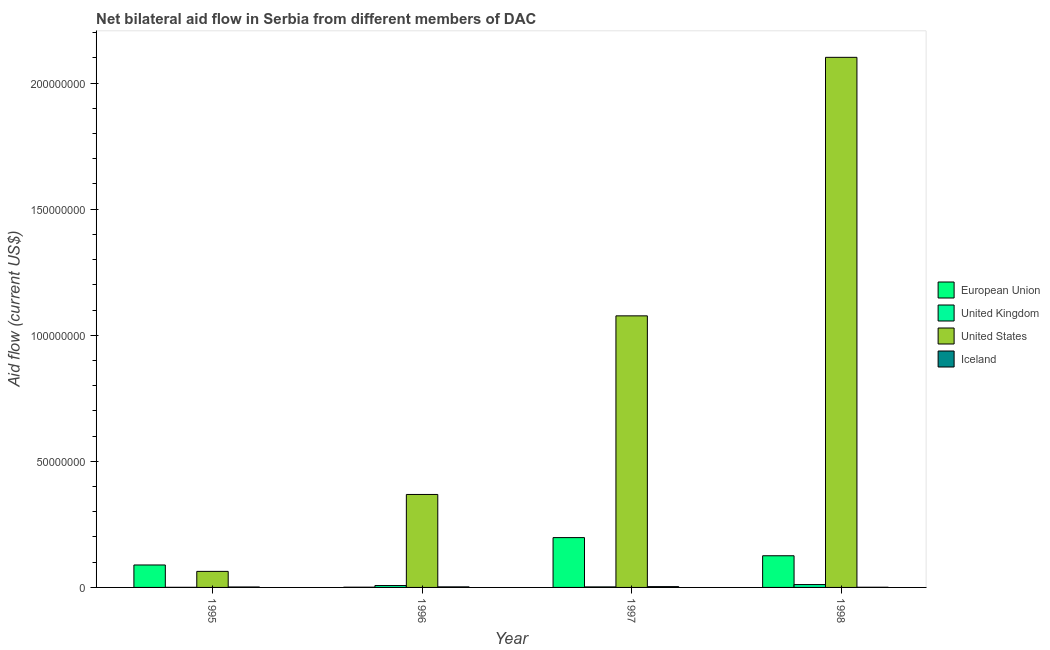How many different coloured bars are there?
Provide a succinct answer. 4. Are the number of bars on each tick of the X-axis equal?
Provide a succinct answer. Yes. How many bars are there on the 4th tick from the left?
Keep it short and to the point. 4. What is the amount of aid given by us in 1998?
Keep it short and to the point. 2.10e+08. Across all years, what is the maximum amount of aid given by uk?
Give a very brief answer. 1.13e+06. Across all years, what is the minimum amount of aid given by uk?
Provide a short and direct response. 4.00e+04. In which year was the amount of aid given by eu maximum?
Offer a very short reply. 1997. In which year was the amount of aid given by us minimum?
Offer a terse response. 1995. What is the total amount of aid given by iceland in the graph?
Offer a terse response. 7.90e+05. What is the difference between the amount of aid given by us in 1996 and that in 1997?
Your answer should be compact. -7.08e+07. What is the difference between the amount of aid given by uk in 1995 and the amount of aid given by eu in 1996?
Your response must be concise. -7.10e+05. What is the average amount of aid given by us per year?
Offer a terse response. 9.03e+07. In how many years, is the amount of aid given by iceland greater than 40000000 US$?
Offer a terse response. 0. What is the ratio of the amount of aid given by us in 1995 to that in 1996?
Offer a very short reply. 0.17. Is the amount of aid given by iceland in 1995 less than that in 1998?
Offer a very short reply. No. Is the difference between the amount of aid given by us in 1995 and 1996 greater than the difference between the amount of aid given by iceland in 1995 and 1996?
Your response must be concise. No. What is the difference between the highest and the second highest amount of aid given by iceland?
Ensure brevity in your answer.  1.00e+05. What is the difference between the highest and the lowest amount of aid given by eu?
Your answer should be very brief. 1.97e+07. Is the sum of the amount of aid given by eu in 1997 and 1998 greater than the maximum amount of aid given by iceland across all years?
Offer a very short reply. Yes. What does the 2nd bar from the left in 1998 represents?
Give a very brief answer. United Kingdom. Is it the case that in every year, the sum of the amount of aid given by eu and amount of aid given by uk is greater than the amount of aid given by us?
Your answer should be very brief. No. Are all the bars in the graph horizontal?
Your answer should be compact. No. What is the difference between two consecutive major ticks on the Y-axis?
Your answer should be compact. 5.00e+07. Are the values on the major ticks of Y-axis written in scientific E-notation?
Give a very brief answer. No. Does the graph contain any zero values?
Give a very brief answer. No. Does the graph contain grids?
Provide a short and direct response. No. Where does the legend appear in the graph?
Ensure brevity in your answer.  Center right. What is the title of the graph?
Your response must be concise. Net bilateral aid flow in Serbia from different members of DAC. Does "United Kingdom" appear as one of the legend labels in the graph?
Your answer should be very brief. Yes. What is the Aid flow (current US$) of European Union in 1995?
Give a very brief answer. 8.90e+06. What is the Aid flow (current US$) in United States in 1995?
Your answer should be compact. 6.36e+06. What is the Aid flow (current US$) in United Kingdom in 1996?
Your response must be concise. 7.50e+05. What is the Aid flow (current US$) in United States in 1996?
Provide a succinct answer. 3.69e+07. What is the Aid flow (current US$) in European Union in 1997?
Your response must be concise. 1.98e+07. What is the Aid flow (current US$) of United States in 1997?
Provide a short and direct response. 1.08e+08. What is the Aid flow (current US$) in European Union in 1998?
Offer a terse response. 1.26e+07. What is the Aid flow (current US$) of United Kingdom in 1998?
Your answer should be very brief. 1.13e+06. What is the Aid flow (current US$) in United States in 1998?
Make the answer very short. 2.10e+08. What is the Aid flow (current US$) in Iceland in 1998?
Ensure brevity in your answer.  7.00e+04. Across all years, what is the maximum Aid flow (current US$) of European Union?
Offer a terse response. 1.98e+07. Across all years, what is the maximum Aid flow (current US$) of United Kingdom?
Keep it short and to the point. 1.13e+06. Across all years, what is the maximum Aid flow (current US$) in United States?
Provide a succinct answer. 2.10e+08. Across all years, what is the maximum Aid flow (current US$) of Iceland?
Your answer should be compact. 3.20e+05. Across all years, what is the minimum Aid flow (current US$) of European Union?
Make the answer very short. 9.00e+04. Across all years, what is the minimum Aid flow (current US$) of United Kingdom?
Your answer should be compact. 4.00e+04. Across all years, what is the minimum Aid flow (current US$) in United States?
Your answer should be compact. 6.36e+06. What is the total Aid flow (current US$) in European Union in the graph?
Provide a short and direct response. 4.13e+07. What is the total Aid flow (current US$) in United Kingdom in the graph?
Provide a short and direct response. 2.13e+06. What is the total Aid flow (current US$) in United States in the graph?
Your response must be concise. 3.61e+08. What is the total Aid flow (current US$) of Iceland in the graph?
Your answer should be very brief. 7.90e+05. What is the difference between the Aid flow (current US$) in European Union in 1995 and that in 1996?
Keep it short and to the point. 8.81e+06. What is the difference between the Aid flow (current US$) in United Kingdom in 1995 and that in 1996?
Give a very brief answer. -7.10e+05. What is the difference between the Aid flow (current US$) in United States in 1995 and that in 1996?
Provide a succinct answer. -3.05e+07. What is the difference between the Aid flow (current US$) of Iceland in 1995 and that in 1996?
Your answer should be compact. -4.00e+04. What is the difference between the Aid flow (current US$) of European Union in 1995 and that in 1997?
Offer a very short reply. -1.09e+07. What is the difference between the Aid flow (current US$) in United Kingdom in 1995 and that in 1997?
Offer a very short reply. -1.70e+05. What is the difference between the Aid flow (current US$) in United States in 1995 and that in 1997?
Make the answer very short. -1.01e+08. What is the difference between the Aid flow (current US$) in Iceland in 1995 and that in 1997?
Ensure brevity in your answer.  -1.40e+05. What is the difference between the Aid flow (current US$) in European Union in 1995 and that in 1998?
Offer a terse response. -3.66e+06. What is the difference between the Aid flow (current US$) of United Kingdom in 1995 and that in 1998?
Offer a terse response. -1.09e+06. What is the difference between the Aid flow (current US$) of United States in 1995 and that in 1998?
Keep it short and to the point. -2.04e+08. What is the difference between the Aid flow (current US$) in Iceland in 1995 and that in 1998?
Offer a very short reply. 1.10e+05. What is the difference between the Aid flow (current US$) of European Union in 1996 and that in 1997?
Offer a very short reply. -1.97e+07. What is the difference between the Aid flow (current US$) of United Kingdom in 1996 and that in 1997?
Keep it short and to the point. 5.40e+05. What is the difference between the Aid flow (current US$) in United States in 1996 and that in 1997?
Ensure brevity in your answer.  -7.08e+07. What is the difference between the Aid flow (current US$) of Iceland in 1996 and that in 1997?
Give a very brief answer. -1.00e+05. What is the difference between the Aid flow (current US$) in European Union in 1996 and that in 1998?
Make the answer very short. -1.25e+07. What is the difference between the Aid flow (current US$) in United Kingdom in 1996 and that in 1998?
Provide a short and direct response. -3.80e+05. What is the difference between the Aid flow (current US$) in United States in 1996 and that in 1998?
Provide a succinct answer. -1.73e+08. What is the difference between the Aid flow (current US$) of European Union in 1997 and that in 1998?
Your answer should be compact. 7.20e+06. What is the difference between the Aid flow (current US$) in United Kingdom in 1997 and that in 1998?
Offer a very short reply. -9.20e+05. What is the difference between the Aid flow (current US$) of United States in 1997 and that in 1998?
Offer a very short reply. -1.03e+08. What is the difference between the Aid flow (current US$) in European Union in 1995 and the Aid flow (current US$) in United Kingdom in 1996?
Ensure brevity in your answer.  8.15e+06. What is the difference between the Aid flow (current US$) of European Union in 1995 and the Aid flow (current US$) of United States in 1996?
Your response must be concise. -2.80e+07. What is the difference between the Aid flow (current US$) of European Union in 1995 and the Aid flow (current US$) of Iceland in 1996?
Ensure brevity in your answer.  8.68e+06. What is the difference between the Aid flow (current US$) in United Kingdom in 1995 and the Aid flow (current US$) in United States in 1996?
Keep it short and to the point. -3.68e+07. What is the difference between the Aid flow (current US$) of United Kingdom in 1995 and the Aid flow (current US$) of Iceland in 1996?
Provide a short and direct response. -1.80e+05. What is the difference between the Aid flow (current US$) of United States in 1995 and the Aid flow (current US$) of Iceland in 1996?
Provide a succinct answer. 6.14e+06. What is the difference between the Aid flow (current US$) of European Union in 1995 and the Aid flow (current US$) of United Kingdom in 1997?
Ensure brevity in your answer.  8.69e+06. What is the difference between the Aid flow (current US$) in European Union in 1995 and the Aid flow (current US$) in United States in 1997?
Offer a terse response. -9.88e+07. What is the difference between the Aid flow (current US$) in European Union in 1995 and the Aid flow (current US$) in Iceland in 1997?
Offer a terse response. 8.58e+06. What is the difference between the Aid flow (current US$) of United Kingdom in 1995 and the Aid flow (current US$) of United States in 1997?
Offer a terse response. -1.08e+08. What is the difference between the Aid flow (current US$) of United Kingdom in 1995 and the Aid flow (current US$) of Iceland in 1997?
Your answer should be very brief. -2.80e+05. What is the difference between the Aid flow (current US$) in United States in 1995 and the Aid flow (current US$) in Iceland in 1997?
Offer a terse response. 6.04e+06. What is the difference between the Aid flow (current US$) in European Union in 1995 and the Aid flow (current US$) in United Kingdom in 1998?
Your response must be concise. 7.77e+06. What is the difference between the Aid flow (current US$) of European Union in 1995 and the Aid flow (current US$) of United States in 1998?
Your answer should be very brief. -2.01e+08. What is the difference between the Aid flow (current US$) in European Union in 1995 and the Aid flow (current US$) in Iceland in 1998?
Make the answer very short. 8.83e+06. What is the difference between the Aid flow (current US$) of United Kingdom in 1995 and the Aid flow (current US$) of United States in 1998?
Ensure brevity in your answer.  -2.10e+08. What is the difference between the Aid flow (current US$) of United States in 1995 and the Aid flow (current US$) of Iceland in 1998?
Make the answer very short. 6.29e+06. What is the difference between the Aid flow (current US$) in European Union in 1996 and the Aid flow (current US$) in United States in 1997?
Keep it short and to the point. -1.08e+08. What is the difference between the Aid flow (current US$) of European Union in 1996 and the Aid flow (current US$) of Iceland in 1997?
Provide a short and direct response. -2.30e+05. What is the difference between the Aid flow (current US$) of United Kingdom in 1996 and the Aid flow (current US$) of United States in 1997?
Ensure brevity in your answer.  -1.07e+08. What is the difference between the Aid flow (current US$) in United States in 1996 and the Aid flow (current US$) in Iceland in 1997?
Make the answer very short. 3.66e+07. What is the difference between the Aid flow (current US$) of European Union in 1996 and the Aid flow (current US$) of United Kingdom in 1998?
Your answer should be compact. -1.04e+06. What is the difference between the Aid flow (current US$) of European Union in 1996 and the Aid flow (current US$) of United States in 1998?
Ensure brevity in your answer.  -2.10e+08. What is the difference between the Aid flow (current US$) in United Kingdom in 1996 and the Aid flow (current US$) in United States in 1998?
Provide a short and direct response. -2.09e+08. What is the difference between the Aid flow (current US$) in United Kingdom in 1996 and the Aid flow (current US$) in Iceland in 1998?
Your answer should be very brief. 6.80e+05. What is the difference between the Aid flow (current US$) in United States in 1996 and the Aid flow (current US$) in Iceland in 1998?
Provide a short and direct response. 3.68e+07. What is the difference between the Aid flow (current US$) of European Union in 1997 and the Aid flow (current US$) of United Kingdom in 1998?
Make the answer very short. 1.86e+07. What is the difference between the Aid flow (current US$) in European Union in 1997 and the Aid flow (current US$) in United States in 1998?
Provide a succinct answer. -1.90e+08. What is the difference between the Aid flow (current US$) in European Union in 1997 and the Aid flow (current US$) in Iceland in 1998?
Give a very brief answer. 1.97e+07. What is the difference between the Aid flow (current US$) in United Kingdom in 1997 and the Aid flow (current US$) in United States in 1998?
Keep it short and to the point. -2.10e+08. What is the difference between the Aid flow (current US$) of United States in 1997 and the Aid flow (current US$) of Iceland in 1998?
Your answer should be very brief. 1.08e+08. What is the average Aid flow (current US$) in European Union per year?
Offer a very short reply. 1.03e+07. What is the average Aid flow (current US$) in United Kingdom per year?
Your answer should be compact. 5.32e+05. What is the average Aid flow (current US$) in United States per year?
Your answer should be compact. 9.03e+07. What is the average Aid flow (current US$) of Iceland per year?
Your response must be concise. 1.98e+05. In the year 1995, what is the difference between the Aid flow (current US$) of European Union and Aid flow (current US$) of United Kingdom?
Offer a very short reply. 8.86e+06. In the year 1995, what is the difference between the Aid flow (current US$) of European Union and Aid flow (current US$) of United States?
Give a very brief answer. 2.54e+06. In the year 1995, what is the difference between the Aid flow (current US$) in European Union and Aid flow (current US$) in Iceland?
Provide a succinct answer. 8.72e+06. In the year 1995, what is the difference between the Aid flow (current US$) of United Kingdom and Aid flow (current US$) of United States?
Offer a very short reply. -6.32e+06. In the year 1995, what is the difference between the Aid flow (current US$) in United Kingdom and Aid flow (current US$) in Iceland?
Provide a short and direct response. -1.40e+05. In the year 1995, what is the difference between the Aid flow (current US$) in United States and Aid flow (current US$) in Iceland?
Offer a very short reply. 6.18e+06. In the year 1996, what is the difference between the Aid flow (current US$) in European Union and Aid flow (current US$) in United Kingdom?
Give a very brief answer. -6.60e+05. In the year 1996, what is the difference between the Aid flow (current US$) of European Union and Aid flow (current US$) of United States?
Offer a very short reply. -3.68e+07. In the year 1996, what is the difference between the Aid flow (current US$) of United Kingdom and Aid flow (current US$) of United States?
Offer a terse response. -3.61e+07. In the year 1996, what is the difference between the Aid flow (current US$) in United Kingdom and Aid flow (current US$) in Iceland?
Your answer should be very brief. 5.30e+05. In the year 1996, what is the difference between the Aid flow (current US$) in United States and Aid flow (current US$) in Iceland?
Offer a terse response. 3.66e+07. In the year 1997, what is the difference between the Aid flow (current US$) in European Union and Aid flow (current US$) in United Kingdom?
Your response must be concise. 1.96e+07. In the year 1997, what is the difference between the Aid flow (current US$) in European Union and Aid flow (current US$) in United States?
Your answer should be very brief. -8.79e+07. In the year 1997, what is the difference between the Aid flow (current US$) in European Union and Aid flow (current US$) in Iceland?
Make the answer very short. 1.94e+07. In the year 1997, what is the difference between the Aid flow (current US$) in United Kingdom and Aid flow (current US$) in United States?
Your answer should be very brief. -1.07e+08. In the year 1997, what is the difference between the Aid flow (current US$) of United Kingdom and Aid flow (current US$) of Iceland?
Keep it short and to the point. -1.10e+05. In the year 1997, what is the difference between the Aid flow (current US$) of United States and Aid flow (current US$) of Iceland?
Your response must be concise. 1.07e+08. In the year 1998, what is the difference between the Aid flow (current US$) of European Union and Aid flow (current US$) of United Kingdom?
Your answer should be compact. 1.14e+07. In the year 1998, what is the difference between the Aid flow (current US$) of European Union and Aid flow (current US$) of United States?
Your response must be concise. -1.98e+08. In the year 1998, what is the difference between the Aid flow (current US$) of European Union and Aid flow (current US$) of Iceland?
Your answer should be compact. 1.25e+07. In the year 1998, what is the difference between the Aid flow (current US$) in United Kingdom and Aid flow (current US$) in United States?
Keep it short and to the point. -2.09e+08. In the year 1998, what is the difference between the Aid flow (current US$) of United Kingdom and Aid flow (current US$) of Iceland?
Offer a terse response. 1.06e+06. In the year 1998, what is the difference between the Aid flow (current US$) of United States and Aid flow (current US$) of Iceland?
Your response must be concise. 2.10e+08. What is the ratio of the Aid flow (current US$) of European Union in 1995 to that in 1996?
Give a very brief answer. 98.89. What is the ratio of the Aid flow (current US$) of United Kingdom in 1995 to that in 1996?
Provide a short and direct response. 0.05. What is the ratio of the Aid flow (current US$) in United States in 1995 to that in 1996?
Your answer should be compact. 0.17. What is the ratio of the Aid flow (current US$) in Iceland in 1995 to that in 1996?
Your answer should be compact. 0.82. What is the ratio of the Aid flow (current US$) of European Union in 1995 to that in 1997?
Make the answer very short. 0.45. What is the ratio of the Aid flow (current US$) of United Kingdom in 1995 to that in 1997?
Your response must be concise. 0.19. What is the ratio of the Aid flow (current US$) in United States in 1995 to that in 1997?
Keep it short and to the point. 0.06. What is the ratio of the Aid flow (current US$) in Iceland in 1995 to that in 1997?
Provide a short and direct response. 0.56. What is the ratio of the Aid flow (current US$) of European Union in 1995 to that in 1998?
Your answer should be compact. 0.71. What is the ratio of the Aid flow (current US$) of United Kingdom in 1995 to that in 1998?
Provide a short and direct response. 0.04. What is the ratio of the Aid flow (current US$) in United States in 1995 to that in 1998?
Offer a terse response. 0.03. What is the ratio of the Aid flow (current US$) of Iceland in 1995 to that in 1998?
Offer a very short reply. 2.57. What is the ratio of the Aid flow (current US$) in European Union in 1996 to that in 1997?
Your response must be concise. 0. What is the ratio of the Aid flow (current US$) in United Kingdom in 1996 to that in 1997?
Make the answer very short. 3.57. What is the ratio of the Aid flow (current US$) of United States in 1996 to that in 1997?
Offer a very short reply. 0.34. What is the ratio of the Aid flow (current US$) of Iceland in 1996 to that in 1997?
Keep it short and to the point. 0.69. What is the ratio of the Aid flow (current US$) of European Union in 1996 to that in 1998?
Give a very brief answer. 0.01. What is the ratio of the Aid flow (current US$) in United Kingdom in 1996 to that in 1998?
Ensure brevity in your answer.  0.66. What is the ratio of the Aid flow (current US$) of United States in 1996 to that in 1998?
Your answer should be compact. 0.18. What is the ratio of the Aid flow (current US$) in Iceland in 1996 to that in 1998?
Your answer should be very brief. 3.14. What is the ratio of the Aid flow (current US$) in European Union in 1997 to that in 1998?
Make the answer very short. 1.57. What is the ratio of the Aid flow (current US$) in United Kingdom in 1997 to that in 1998?
Offer a terse response. 0.19. What is the ratio of the Aid flow (current US$) of United States in 1997 to that in 1998?
Offer a terse response. 0.51. What is the ratio of the Aid flow (current US$) in Iceland in 1997 to that in 1998?
Your answer should be very brief. 4.57. What is the difference between the highest and the second highest Aid flow (current US$) in European Union?
Offer a terse response. 7.20e+06. What is the difference between the highest and the second highest Aid flow (current US$) of United Kingdom?
Give a very brief answer. 3.80e+05. What is the difference between the highest and the second highest Aid flow (current US$) in United States?
Give a very brief answer. 1.03e+08. What is the difference between the highest and the lowest Aid flow (current US$) in European Union?
Ensure brevity in your answer.  1.97e+07. What is the difference between the highest and the lowest Aid flow (current US$) of United Kingdom?
Offer a terse response. 1.09e+06. What is the difference between the highest and the lowest Aid flow (current US$) of United States?
Make the answer very short. 2.04e+08. 